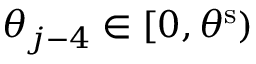Convert formula to latex. <formula><loc_0><loc_0><loc_500><loc_500>\theta _ { j - 4 } \in [ 0 , \theta ^ { s } )</formula> 